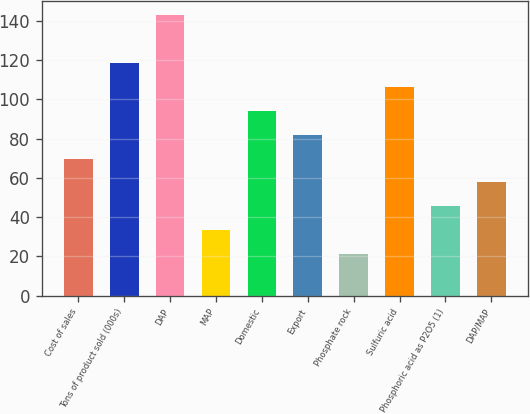<chart> <loc_0><loc_0><loc_500><loc_500><bar_chart><fcel>Cost of sales<fcel>Tons of product sold (000s)<fcel>DAP<fcel>MAP<fcel>Domestic<fcel>Export<fcel>Phosphate rock<fcel>Sulfuric acid<fcel>Phosphoric acid as P2O5 (1)<fcel>DAP/MAP<nl><fcel>69.8<fcel>118.6<fcel>143<fcel>33.2<fcel>94.2<fcel>82<fcel>21<fcel>106.4<fcel>45.4<fcel>57.6<nl></chart> 